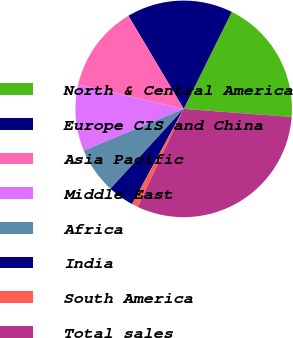Convert chart. <chart><loc_0><loc_0><loc_500><loc_500><pie_chart><fcel>North & Central America<fcel>Europe CIS and China<fcel>Asia Pacific<fcel>Middle East<fcel>Africa<fcel>India<fcel>South America<fcel>Total sales<nl><fcel>18.85%<fcel>15.86%<fcel>12.87%<fcel>9.89%<fcel>6.9%<fcel>3.91%<fcel>0.92%<fcel>30.8%<nl></chart> 